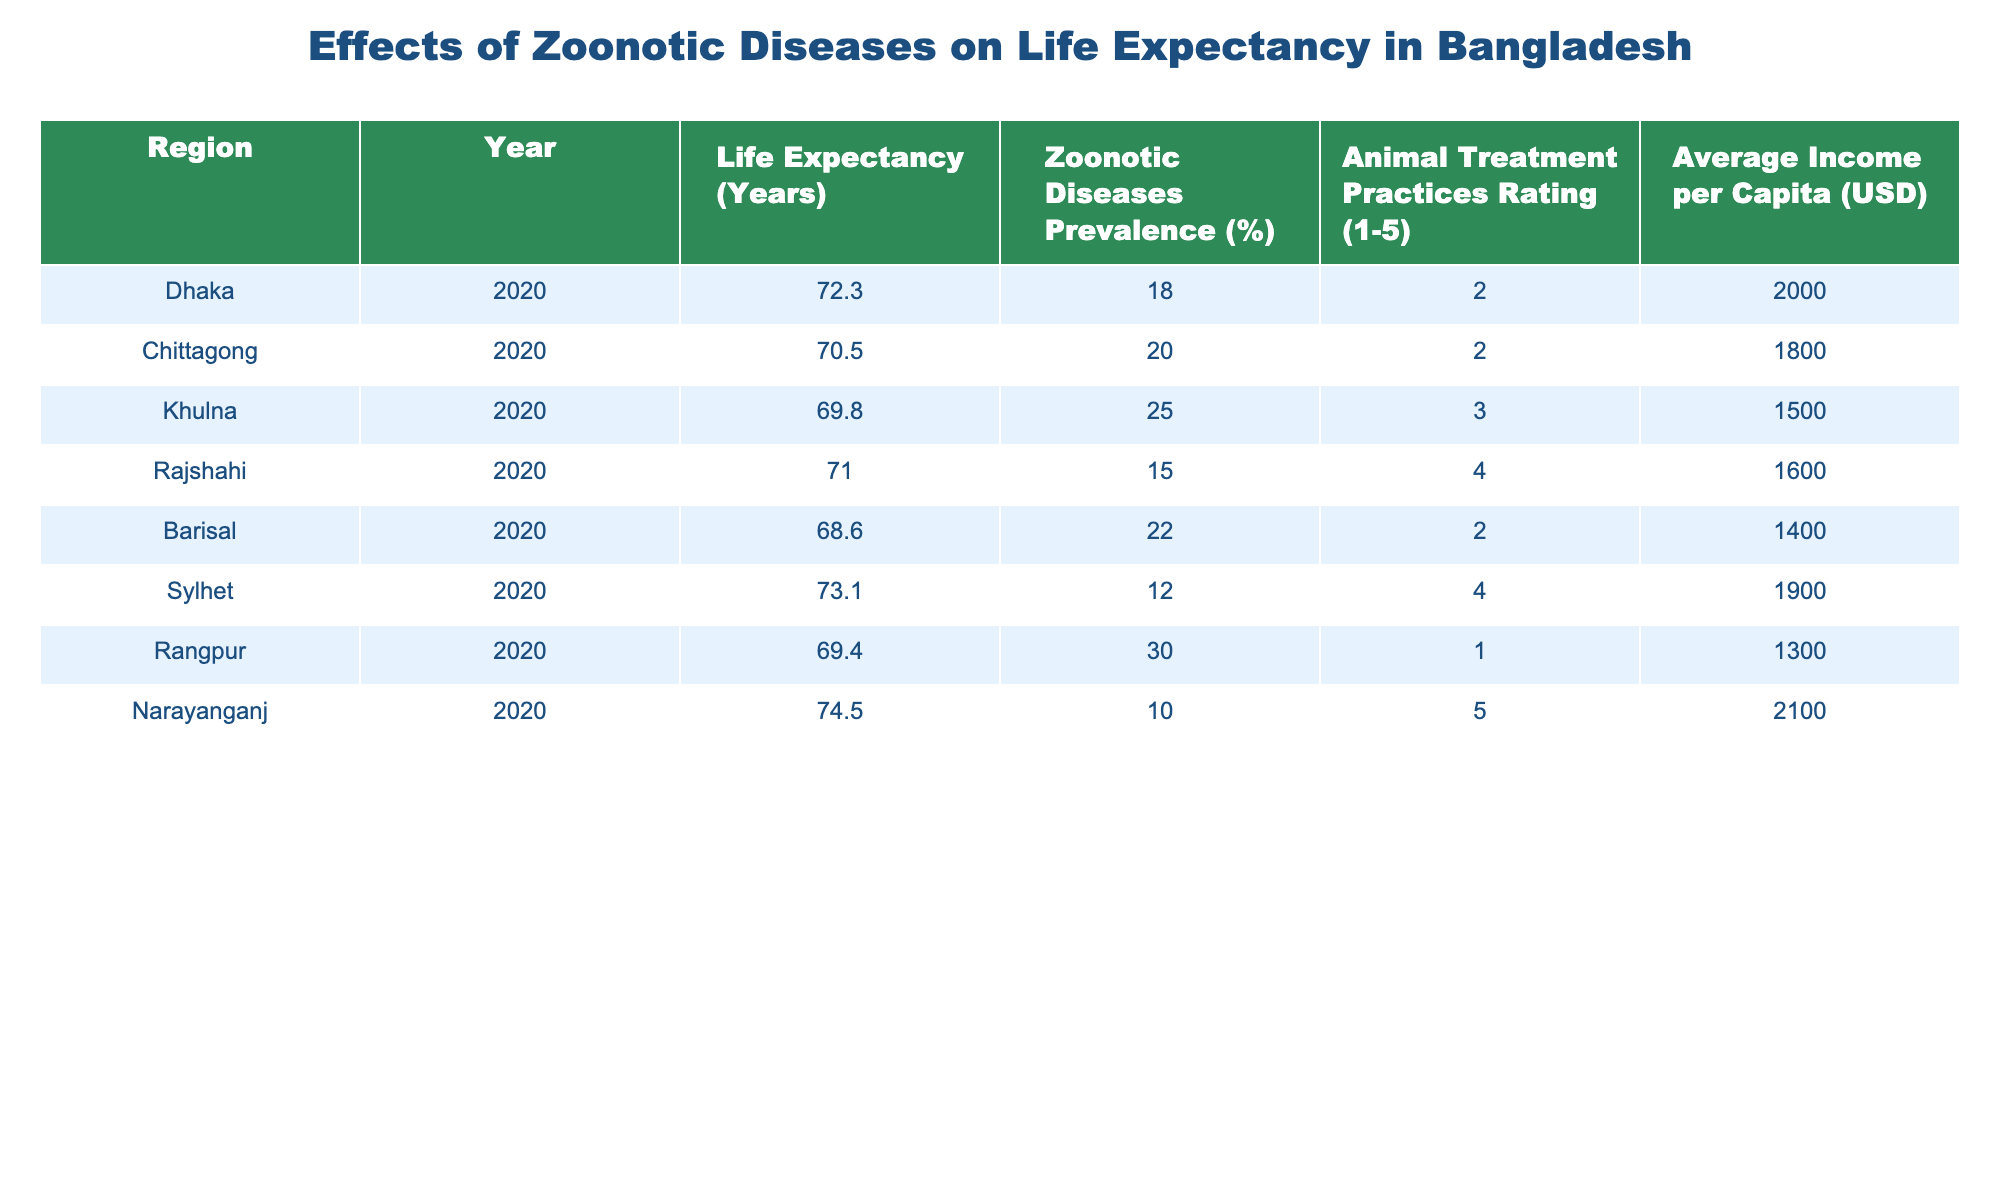What is the life expectancy in Dhaka? The table shows the life expectancy for each region in the specified year. For Dhaka, the entry under "Life Expectancy (Years)" is 72.3.
Answer: 72.3 Which region has the highest animal treatment practices rating? By looking at the "Animal Treatment Practices Rating" column, we can see that Narayanganj has the highest rating of 5.
Answer: Narayanganj What is the average life expectancy for regions with a zoonotic diseases prevalence greater than 20%? The regions with zoonotic diseases prevalence greater than 20% are Khulna (69.8), Chittagong (70.5), and Rangpur (69.4). To find the average, we sum these values: 69.8 + 70.5 + 69.4 = 209.7, and then divide by 3, which gives us an average of 69.9.
Answer: 69.9 Does Sylhet have a higher life expectancy than Rajshahi? From the table, Sylhet's life expectancy is 73.1 while Rajshahi's is 71.0. Since 73.1 is greater than 71.0, the statement is true.
Answer: Yes What is the difference in life expectancy between Narayanganj and Rangpur? Narayanganj has a life expectancy of 74.5 while Rangpur has 69.4. The difference is calculated by subtracting the lower value from the higher value: 74.5 - 69.4 = 5.1.
Answer: 5.1 Which region shows the lowest average income per capita and what is it? Looking through the "Average Income per Capita (USD)" column, Rangpur has the lowest income of 1300 USD.
Answer: Rangpur, 1300 If the zoonotic diseases prevalence in Khulna increased by 5%, what would be the new prevalence? The current prevalence in Khulna is 25%. If it increases by 5%, the new value would be 25 + 5 = 30%.
Answer: 30 How does the life expectancy of regions with a treatment practices rating of 2 compare to those with a rating of 4? Regions with a rating of 2 are Dhaka, Chittagong, and Barisal, with life expectancies of 72.3, 70.5, and 68.6, respectively, giving an average of (72.3 + 70.5 + 68.6) / 3 = 70.47. Regions with a rating of 4 are Rajshahi and Sylhet, with life expectancies of 71.0 and 73.1, respectively, giving an average of (71.0 + 73.1) / 2 = 72.05. Comparing the two averages: 70.47 (rating 2) is less than 72.05 (rating 4).
Answer: Rating 2 (lower) compared to rating 4 (higher) 